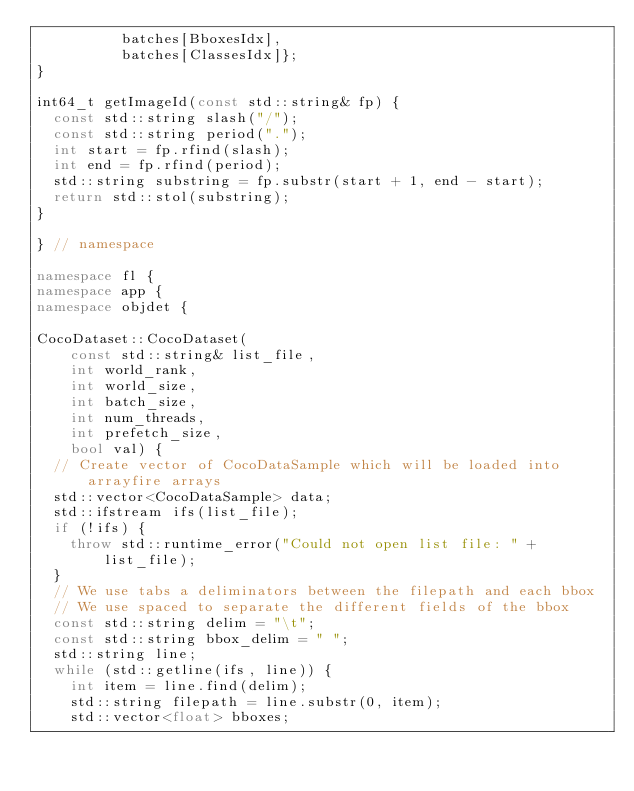<code> <loc_0><loc_0><loc_500><loc_500><_C++_>          batches[BboxesIdx],
          batches[ClassesIdx]};
}

int64_t getImageId(const std::string& fp) {
  const std::string slash("/");
  const std::string period(".");
  int start = fp.rfind(slash);
  int end = fp.rfind(period);
  std::string substring = fp.substr(start + 1, end - start);
  return std::stol(substring);
}

} // namespace

namespace fl {
namespace app {
namespace objdet {

CocoDataset::CocoDataset(
    const std::string& list_file,
    int world_rank,
    int world_size,
    int batch_size,
    int num_threads,
    int prefetch_size,
    bool val) {
  // Create vector of CocoDataSample which will be loaded into arrayfire arrays
  std::vector<CocoDataSample> data;
  std::ifstream ifs(list_file);
  if (!ifs) {
    throw std::runtime_error("Could not open list file: " + list_file);
  }
  // We use tabs a deliminators between the filepath and each bbox
  // We use spaced to separate the different fields of the bbox
  const std::string delim = "\t";
  const std::string bbox_delim = " ";
  std::string line;
  while (std::getline(ifs, line)) {
    int item = line.find(delim);
    std::string filepath = line.substr(0, item);
    std::vector<float> bboxes;</code> 